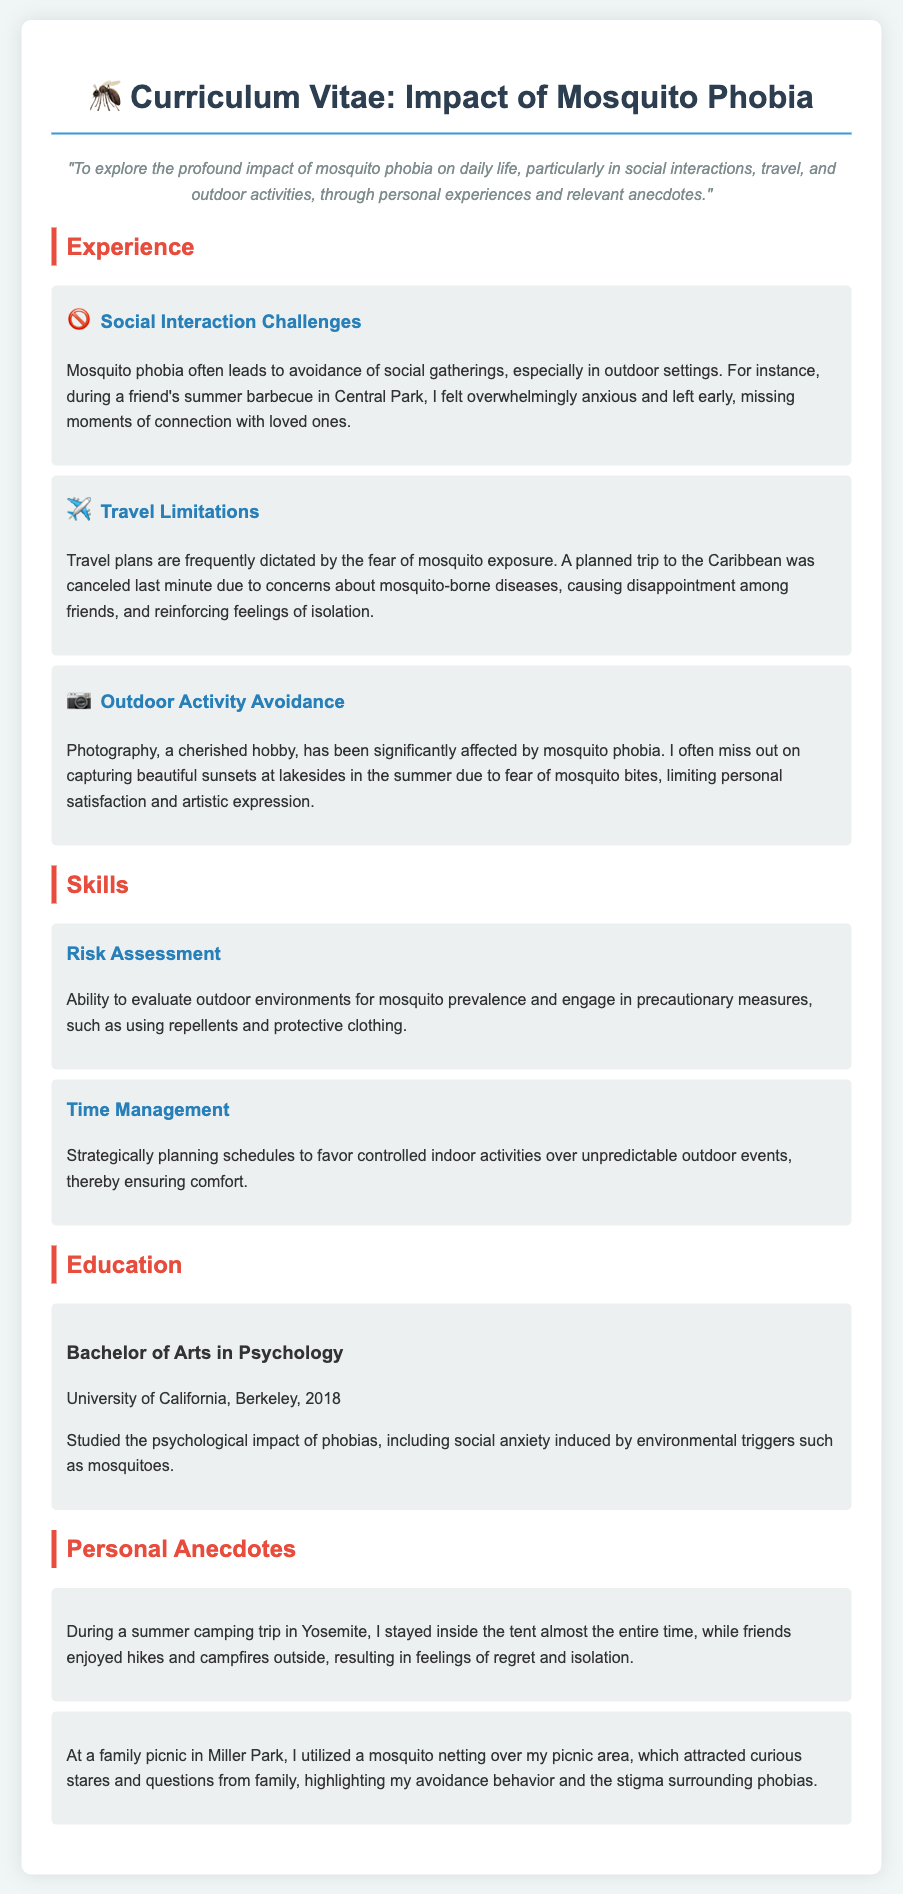What is the primary focus of the CV? The CV explores the impact of mosquito phobia on daily life, especially in social interactions, travel, and outdoor activities.
Answer: Impact of mosquito phobia What degree does the individual hold? The document mentions a Bachelor of Arts degree in Psychology from the University of California, Berkeley.
Answer: Bachelor of Arts in Psychology What year did the person graduate? The graduation year is specified in the document as 2018.
Answer: 2018 What emotional impact did the mosquito phobia have during a friend's barbecue? The document states that the anxiety led to leaving early and missing moments of connection.
Answer: Missing moments of connection What type of outdoor activity does the individual enjoy but avoids? The CV lists photography as a cherished hobby that is significantly affected by the phobia.
Answer: Photography How does the individual manage their activities due to mosquito phobia? The CV indicates they strategically plan schedules to favor controlled indoor activities.
Answer: Controlled indoor activities What equipment does the individual use at a picnic to deal with their phobia? The document mentions using mosquito netting over the picnic area.
Answer: Mosquito netting What location is associated with the regrettable camping experience mentioned? The camping experience is linked to Yosemite, where the individual stayed inside the tent.
Answer: Yosemite What specific mosquito-related skill is highlighted in the skills section? The individual has the ability to evaluate outdoor environments for mosquito prevalence.
Answer: Risk Assessment 